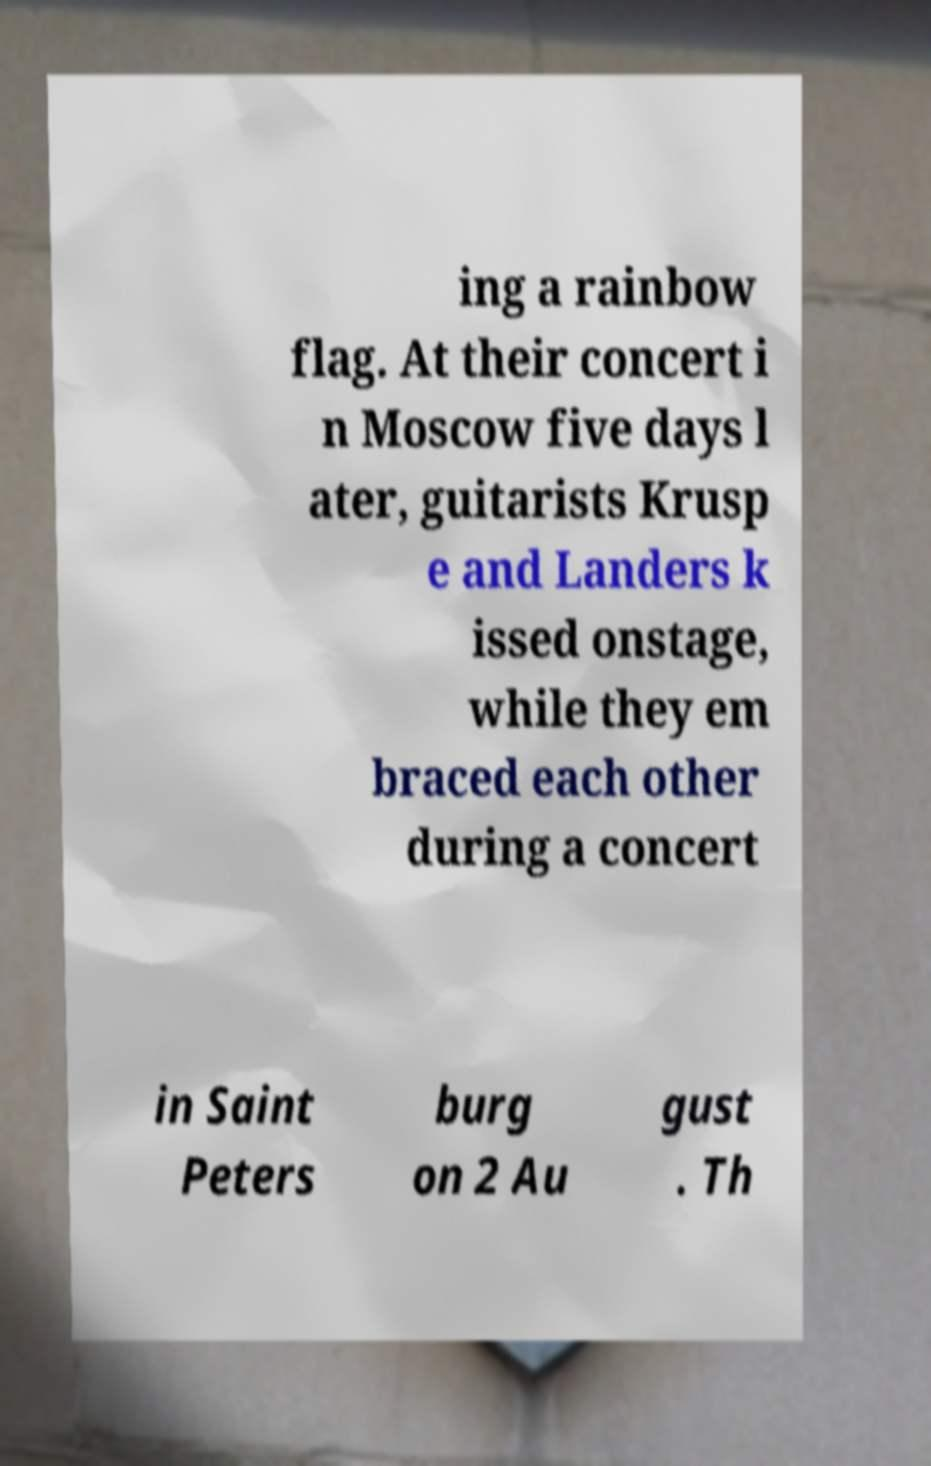Can you accurately transcribe the text from the provided image for me? ing a rainbow flag. At their concert i n Moscow five days l ater, guitarists Krusp e and Landers k issed onstage, while they em braced each other during a concert in Saint Peters burg on 2 Au gust . Th 